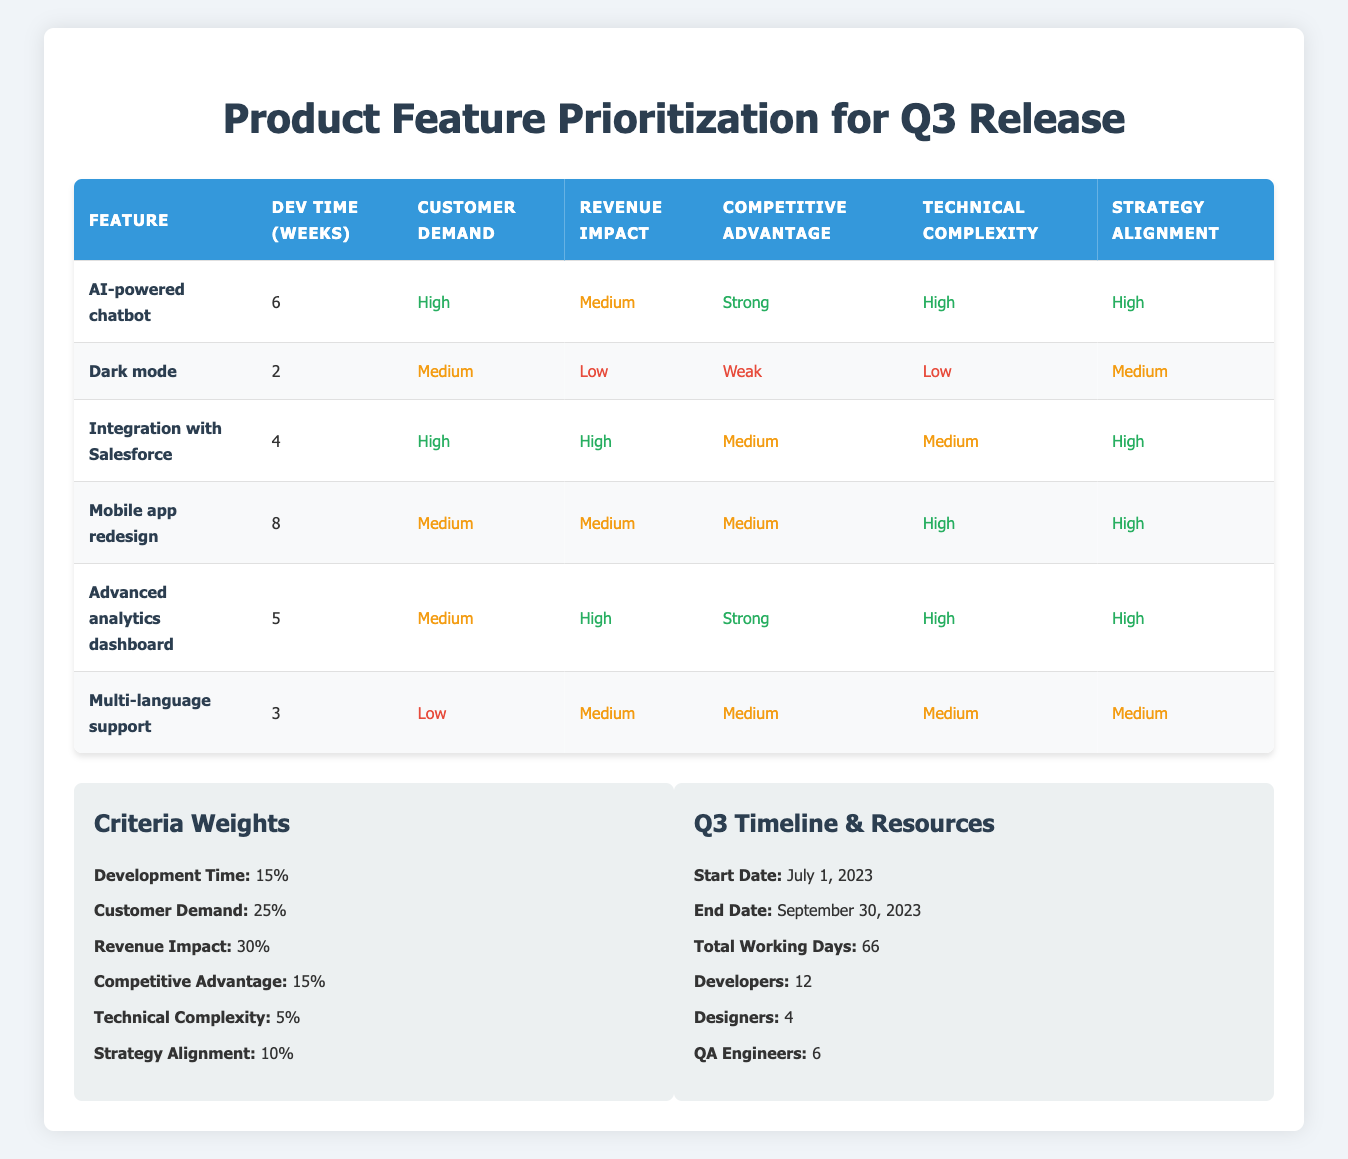What feature has the longest development time? By looking at the "Development Time (weeks)" column, the feature with the highest value is "Mobile app redesign," which takes 8 weeks.
Answer: Mobile app redesign Which features have a "High" customer demand? In the "Customer Demand" column, I find "AI-powered chatbot" and "Integration with Salesforce" marked as "High."
Answer: AI-powered chatbot, Integration with Salesforce What is the revenue impact of the "Advanced analytics dashboard"? Checking the "Revenue Impact" column, the "Advanced analytics dashboard" is categorized as "High."
Answer: High Is the "Dark mode" feature aligned with the strategy? The "Alignment with Strategy" for "Dark mode" is listed as "Medium," which indicates that it is not strongly aligned with the strategy.
Answer: No Which feature(s) take less than four weeks to develop? Analyzing the "Dev Time (weeks)" column, the only feature with less than four weeks is "Dark mode," which takes 2 weeks, and "Multi-language support," which takes 3 weeks.
Answer: Dark mode, Multi-language support What is the average development time for all features? The development times are 6, 2, 4, 8, 5, and 3 weeks respectively. Summing these gives 28 weeks. Dividing by the number of features (6), the average development time is 28/6 = 4.67 weeks.
Answer: 4.67 weeks Which feature has the strongest competitive advantage and what is its alignment with strategy? "AI-powered chatbot" and "Advanced analytics dashboard" are both categorized as "Strong" for competitive advantage. Looking at their strategy alignment, both have "High."
Answer: AI-powered chatbot, Advanced analytics dashboard; High Is there a feature with "Low" revenue impact and "High" technical complexity? By checking the "Technical Complexity" and "Revenue Impact" columns, I see that all features with "Low" revenue impact do not have "High" technical complexity. Thus, no such feature exists.
Answer: No What is the total number of features that align with strategy at "High"? From the table, the features that have "High" in the "Alignment with Strategy" column are "AI-powered chatbot," "Integration with Salesforce," "Mobile app redesign," "Advanced analytics dashboard." Counting these gives a total of 4 features.
Answer: 4 